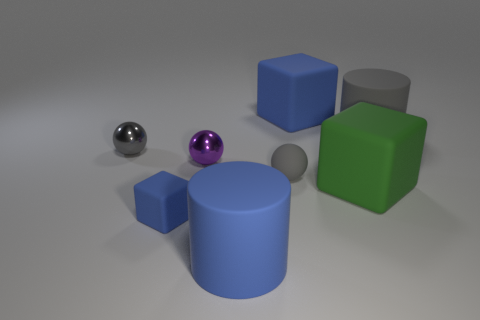There is a tiny object that is the same color as the rubber ball; what material is it?
Make the answer very short. Metal. How many objects are large blue objects that are in front of the large blue block or small matte spheres?
Ensure brevity in your answer.  2. What color is the ball that is the same material as the tiny cube?
Ensure brevity in your answer.  Gray. Is there a blue rubber cube that has the same size as the green cube?
Keep it short and to the point. Yes. Do the big cylinder on the left side of the big green matte cube and the tiny cube have the same color?
Give a very brief answer. Yes. There is a thing that is both to the left of the purple shiny thing and to the right of the tiny gray metallic thing; what is its color?
Keep it short and to the point. Blue. There is a gray matte thing that is the same size as the green rubber object; what shape is it?
Provide a short and direct response. Cylinder. Are there any large blue matte objects of the same shape as the tiny blue rubber thing?
Ensure brevity in your answer.  Yes. There is a matte object right of the green rubber block; is its size the same as the purple object?
Give a very brief answer. No. There is a matte thing that is both on the right side of the large blue cube and behind the green rubber block; what is its size?
Your answer should be compact. Large. 